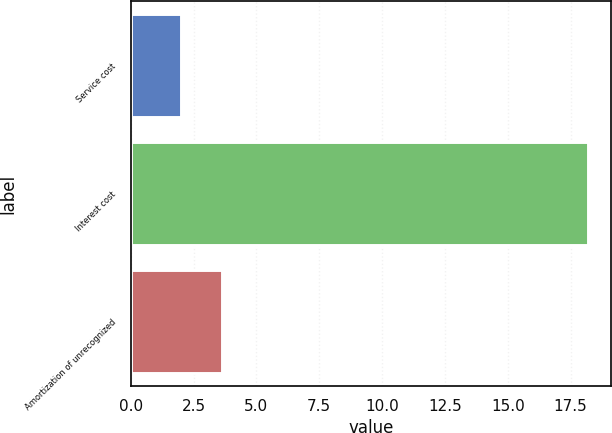Convert chart. <chart><loc_0><loc_0><loc_500><loc_500><bar_chart><fcel>Service cost<fcel>Interest cost<fcel>Amortization of unrecognized<nl><fcel>2<fcel>18.2<fcel>3.62<nl></chart> 